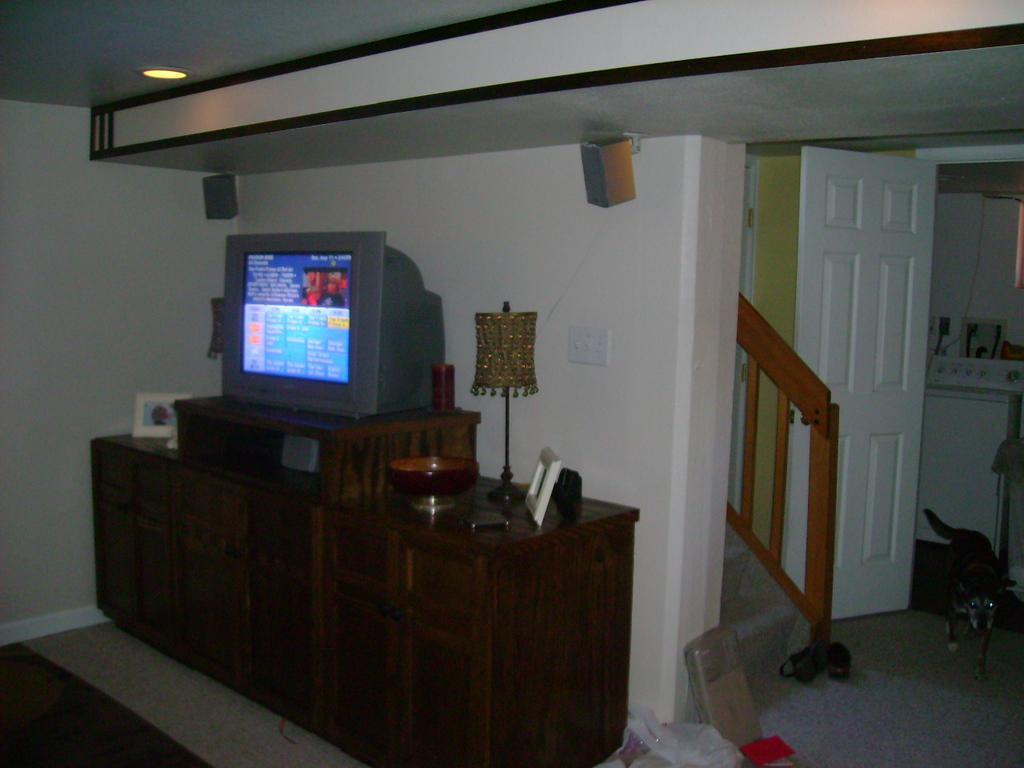How would you summarize this image in a sentence or two? In this image we can see a living room with a table containing a television, photo frame, lamp, bowl and a cellphone on it. On the backside we can see a wall, speakers, roof and ceiling lights. On the right side we can see a dog, door, stairs, shoes and a box on the floor. 